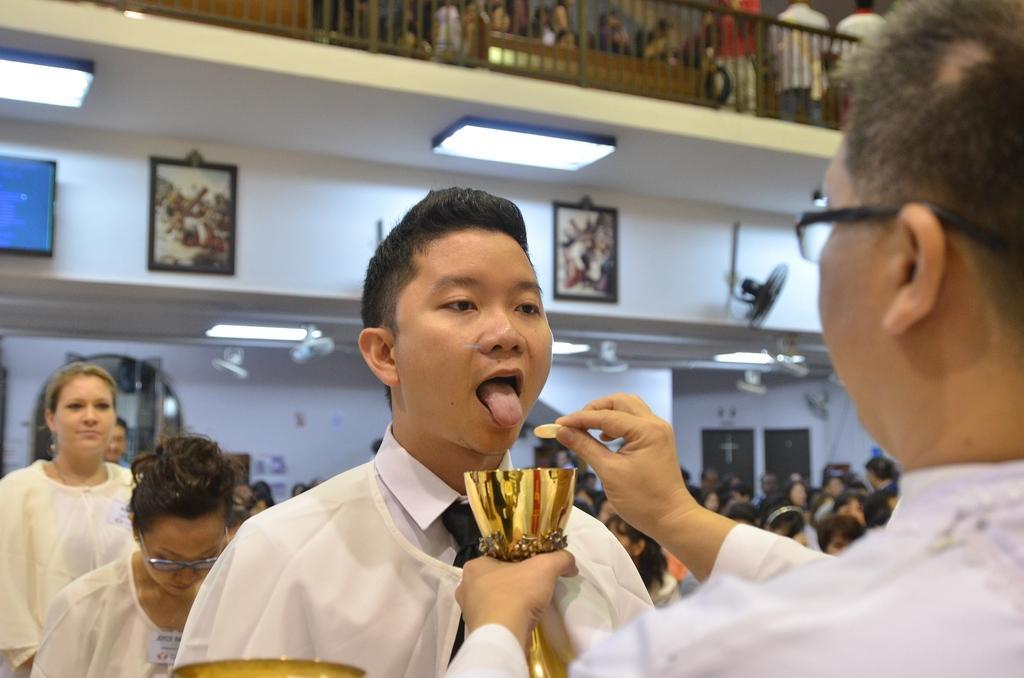Please provide a concise description of this image. In this image there is a men and he is wearing white dress stretching his hand and holding a bowl, in front of him there is a another man, he is wearing a white color dress and opening his mouth, beside him there are two women and their few persons sitting in chairs and there is wall on that wall there are photo frames and fans. 